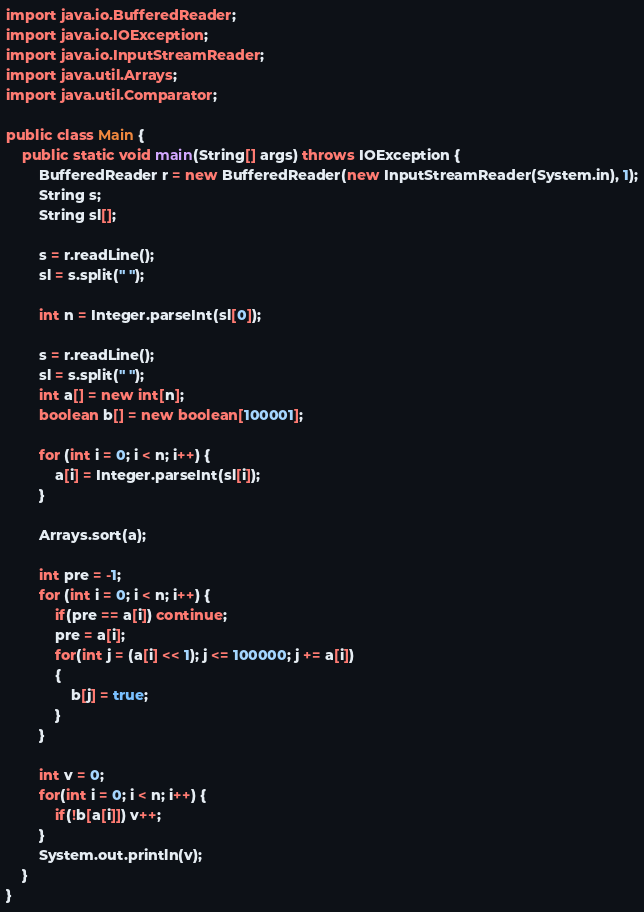Convert code to text. <code><loc_0><loc_0><loc_500><loc_500><_Java_>import java.io.BufferedReader;
import java.io.IOException;
import java.io.InputStreamReader;
import java.util.Arrays;
import java.util.Comparator;

public class Main {
	public static void main(String[] args) throws IOException {
		BufferedReader r = new BufferedReader(new InputStreamReader(System.in), 1);
		String s;
		String sl[];

		s = r.readLine();
		sl = s.split(" ");

		int n = Integer.parseInt(sl[0]);

		s = r.readLine();
		sl = s.split(" ");
		int a[] = new int[n];
		boolean b[] = new boolean[100001];

		for (int i = 0; i < n; i++) {
			a[i] = Integer.parseInt(sl[i]);
		}

		Arrays.sort(a);

		int pre = -1;
		for (int i = 0; i < n; i++) {
			if(pre == a[i]) continue;
			pre = a[i];
			for(int j = (a[i] << 1); j <= 100000; j += a[i])
			{
				b[j] = true;
			}
		}

		int v = 0;
		for(int i = 0; i < n; i++) {
			if(!b[a[i]]) v++;
		}
		System.out.println(v);
	}
}
</code> 